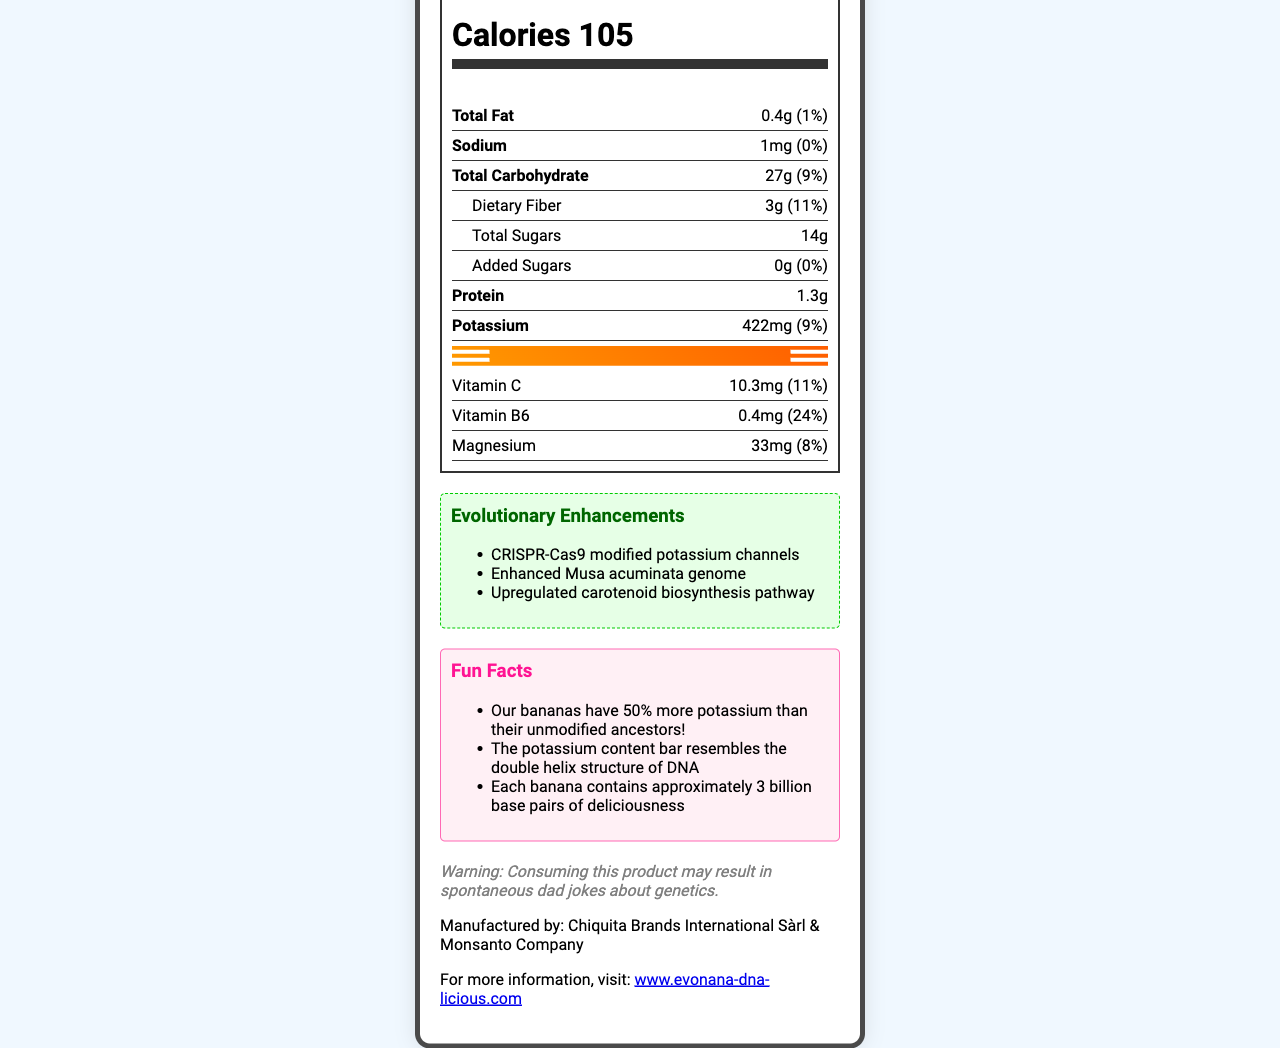what is the serving size of EvoNana? The serving size is explicitly listed as "1 medium banana (118g)" in the document.
Answer: 1 medium banana (118g) how many calories are in one serving of EvoNana? The document specifies that there are 105 calories per serving.
Answer: 105 what is the protein content per serving? The document shows the protein content as "1.3g" per serving.
Answer: 1.3g how much dietary fiber is in EvoNana and what percentage of the daily value does it represent? The dietary fiber content is listed as "3g," which represents "11%" of the daily value.
Answer: 3g, 11% is there any added sugar in EvoNana? The document states that the added sugars amount is "0g" with a daily value of "0%".
Answer: No what evolutionary enhancements have been made to EvoNana? Three evolutionary enhancements are listed: "CRISPR-Cas9 modified potassium channels," "Enhanced Musa acuminata genome," and "Upregulated carotenoid biosynthesis pathway."
Answer: CRISPR-Cas9 modified potassium channels, Enhanced Musa acuminata genome, Upregulated carotenoid biosynthesis pathway what is special about the potassium content in EvoNana? The document includes a fun fact mentioning that the potassium content bar resembles the double helix structure of DNA.
Answer: The potassium content bar resembles the double helix structure of DNA what allergens might EvoNana contain? The allergen information in the document states that EvoNana contains banana DNA and may contain traces of Drosophila melanogaster genes.
Answer: Contains banana DNA. May contain traces of Drosophila melanogaster genes. what company manufactures EvoNana? The manufacturer is listed as "Chiquita Brands International Sàrl & Monsanto Company."
Answer: Chiquita Brands International Sàrl & Monsanto Company what is the website for more information about EvoNana? The document provides the website as "www.evonana-dna-licious.com."
Answer: www.evonana-dna-licious.com which of the following vitamins has the highest daily value percentage in EvoNana? A. Vitamin C B. Vitamin B6 C. Magnesium Vitamin B6 has a daily value percentage of 24%, while Vitamin C is 11% and Magnesium is 8%.
Answer: B. Vitamin B6 how much potassium does EvoNana contain per serving? A. 330mg B. 422mg C. 300mg The document lists the potassium content per serving as "422mg."
Answer: B. 422mg does EvoNana contain any sodium? The document shows that EvoNana contains "1mg" of sodium.
Answer: Yes what are some fun facts about EvoNana mentioned in the document? These facts are listed under the "Fun Facts" section.
Answer: EvoNana has 50% more potassium than their unmodified ancestors! The potassium content bar resembles the double helix structure of DNA. Each banana contains approximately 3 billion base pairs of deliciousness. can you calculate the total carbohydrate content per container, if there are multiple servings in each container? The document specifies "servings per container: 1," thus there is insufficient information to calculate for multiple servings.
Answer: Not enough information summarize the main idea of the document. The document comprehensively details the nutritional information and unique genetic modifications of EvoNana™, along with fun facts and essential details for consumers.
Answer: The document provides detailed nutrition facts for the EvoNana™, a genetically modified banana. It highlights the serving size, calorie count, and various nutritional contents including fats, carbohydrates, proteins, and vitamins. Special features include enhanced potassium content represented in a DNA-shaped bar. The document also mentions evolutionary enhancements through CRISPR-Cas9, potential allergens, and fun facts about the genetically modified banana. The manufacturer's name and website are also provided. 